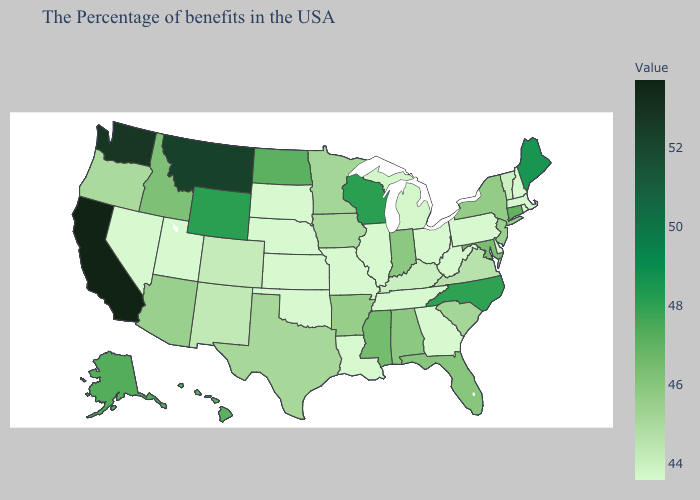Among the states that border Michigan , which have the lowest value?
Answer briefly. Ohio. Does Minnesota have the lowest value in the USA?
Concise answer only. No. Does the map have missing data?
Answer briefly. No. Among the states that border Arkansas , does Mississippi have the highest value?
Give a very brief answer. Yes. Among the states that border New Jersey , which have the highest value?
Give a very brief answer. New York. 